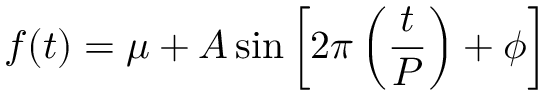<formula> <loc_0><loc_0><loc_500><loc_500>f ( t ) = \mu + A \sin { \left [ 2 \pi \left ( \frac { t } { P } \right ) + \phi \right ] }</formula> 